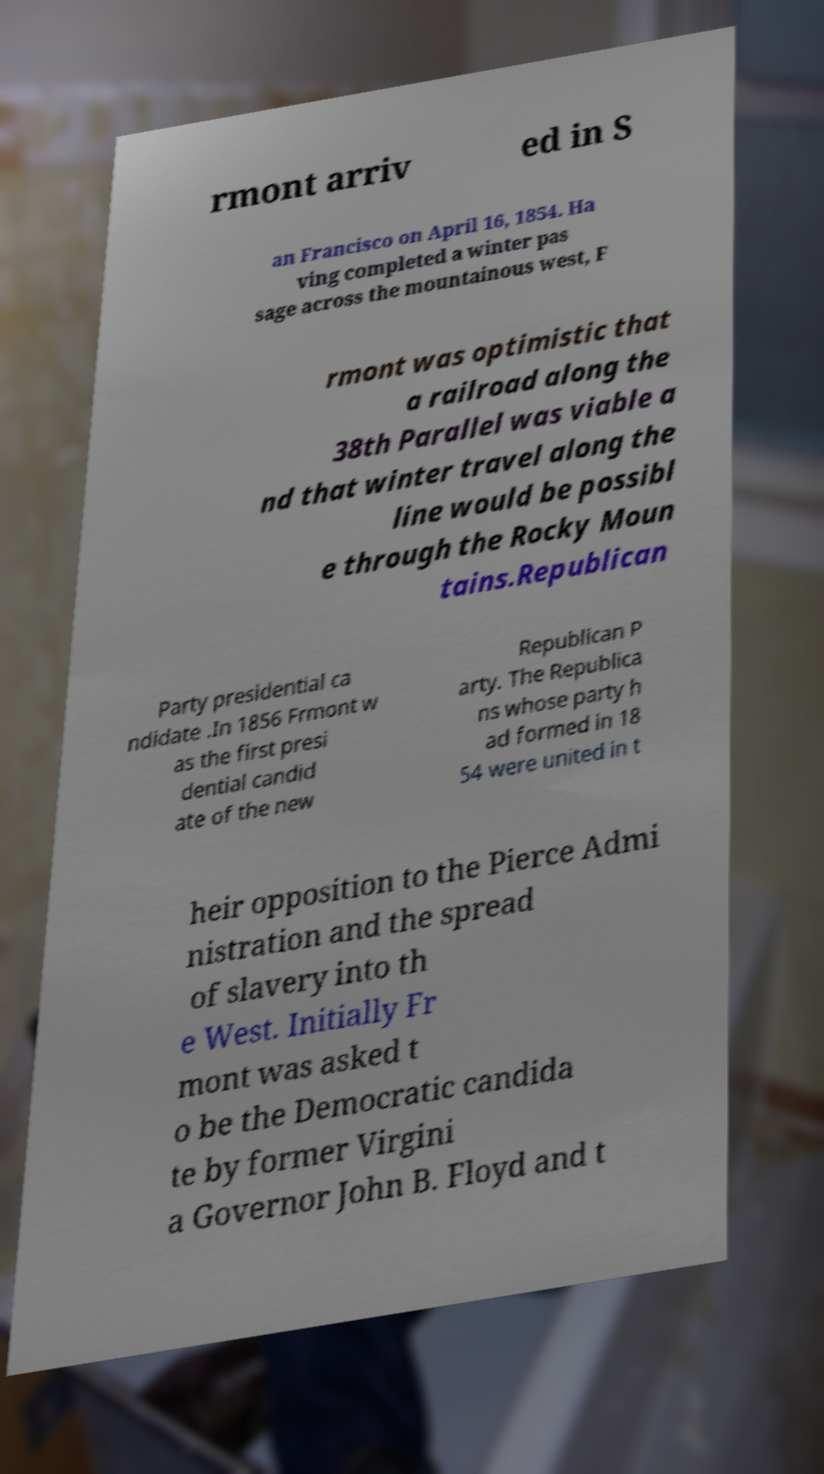Can you read and provide the text displayed in the image?This photo seems to have some interesting text. Can you extract and type it out for me? rmont arriv ed in S an Francisco on April 16, 1854. Ha ving completed a winter pas sage across the mountainous west, F rmont was optimistic that a railroad along the 38th Parallel was viable a nd that winter travel along the line would be possibl e through the Rocky Moun tains.Republican Party presidential ca ndidate .In 1856 Frmont w as the first presi dential candid ate of the new Republican P arty. The Republica ns whose party h ad formed in 18 54 were united in t heir opposition to the Pierce Admi nistration and the spread of slavery into th e West. Initially Fr mont was asked t o be the Democratic candida te by former Virgini a Governor John B. Floyd and t 